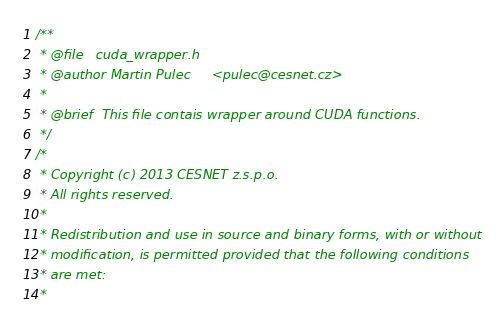<code> <loc_0><loc_0><loc_500><loc_500><_Cuda_>/**
 * @file   cuda_wrapper.h
 * @author Martin Pulec     <pulec@cesnet.cz>
 *
 * @brief  This file contais wrapper around CUDA functions.
 */
/*
 * Copyright (c) 2013 CESNET z.s.p.o.
 * All rights reserved.
 *
 * Redistribution and use in source and binary forms, with or without
 * modification, is permitted provided that the following conditions
 * are met:
 *</code> 